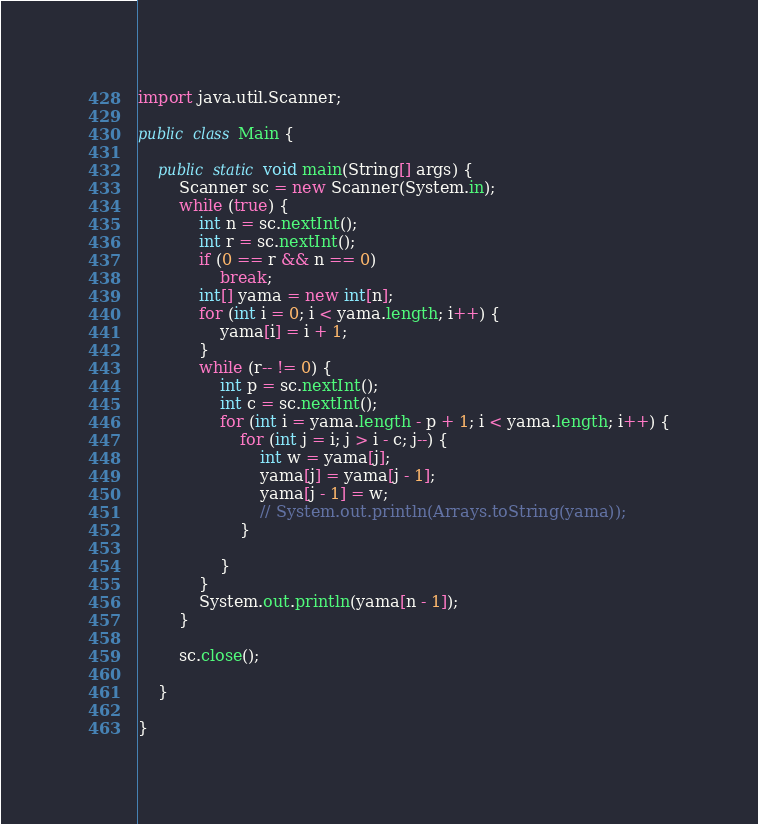Convert code to text. <code><loc_0><loc_0><loc_500><loc_500><_Java_>import java.util.Scanner;

public class Main {

	public static void main(String[] args) {
		Scanner sc = new Scanner(System.in);
		while (true) {
			int n = sc.nextInt();
			int r = sc.nextInt();
			if (0 == r && n == 0)
				break;
			int[] yama = new int[n];
			for (int i = 0; i < yama.length; i++) {
				yama[i] = i + 1;
			}
			while (r-- != 0) {
				int p = sc.nextInt();
				int c = sc.nextInt();
				for (int i = yama.length - p + 1; i < yama.length; i++) {
					for (int j = i; j > i - c; j--) {
						int w = yama[j];
						yama[j] = yama[j - 1];
						yama[j - 1] = w;
						// System.out.println(Arrays.toString(yama));
					}

				}
			}
			System.out.println(yama[n - 1]);
		}

		sc.close();

	}

}</code> 